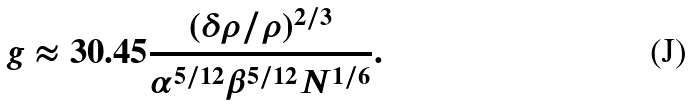<formula> <loc_0><loc_0><loc_500><loc_500>g \approx 3 0 . 4 5 \frac { ( \delta \rho / \rho ) ^ { 2 / 3 } } { \alpha ^ { 5 / 1 2 } \beta ^ { 5 / 1 2 } N ^ { 1 / 6 } } .</formula> 